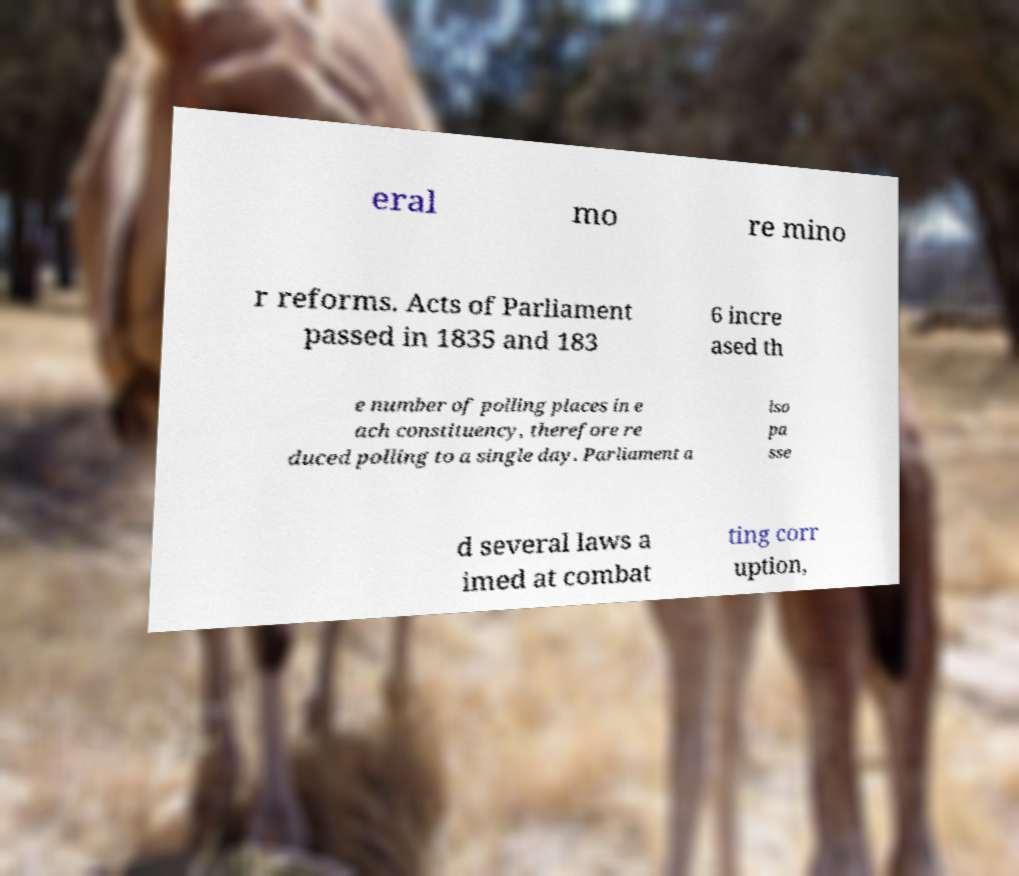Can you accurately transcribe the text from the provided image for me? eral mo re mino r reforms. Acts of Parliament passed in 1835 and 183 6 incre ased th e number of polling places in e ach constituency, therefore re duced polling to a single day. Parliament a lso pa sse d several laws a imed at combat ting corr uption, 